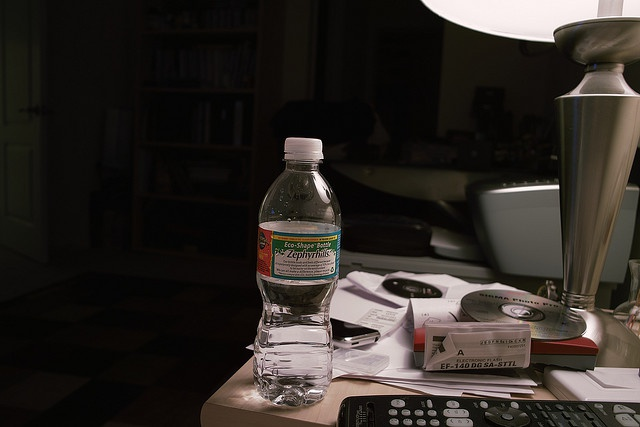Describe the objects in this image and their specific colors. I can see bottle in black, gray, and darkgray tones, remote in black and gray tones, book in black tones, cell phone in black, darkgray, and gray tones, and book in black tones in this image. 